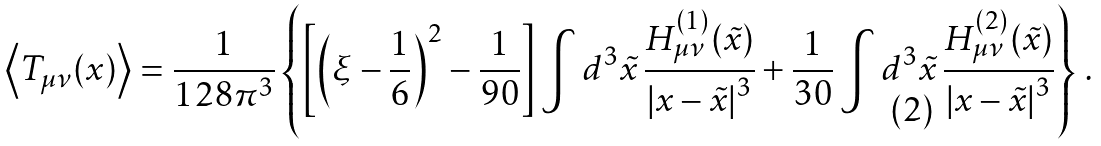<formula> <loc_0><loc_0><loc_500><loc_500>\left \langle T _ { \mu \nu } ( x ) \right \rangle = \frac { 1 } { 1 2 8 \pi ^ { 3 } } \left \{ \left [ \left ( \xi - \frac { 1 } { 6 } \right ) ^ { 2 } - \frac { 1 } { 9 0 } \right ] \int d ^ { 3 } \tilde { x } \, \frac { H _ { \mu \nu } ^ { ( 1 ) } ( \tilde { x } ) } { \left | x - \tilde { x } \right | ^ { 3 } } + \frac { 1 } { 3 0 } \int d ^ { 3 } \tilde { x } \, \frac { H _ { \mu \nu } ^ { ( 2 ) } ( \tilde { x } ) } { \left | x - \tilde { x } \right | ^ { 3 } } \right \} \, .</formula> 